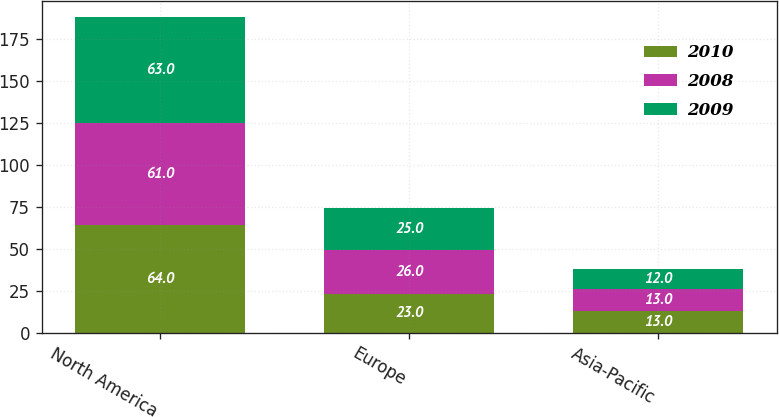<chart> <loc_0><loc_0><loc_500><loc_500><stacked_bar_chart><ecel><fcel>North America<fcel>Europe<fcel>Asia-Pacific<nl><fcel>2010<fcel>64<fcel>23<fcel>13<nl><fcel>2008<fcel>61<fcel>26<fcel>13<nl><fcel>2009<fcel>63<fcel>25<fcel>12<nl></chart> 